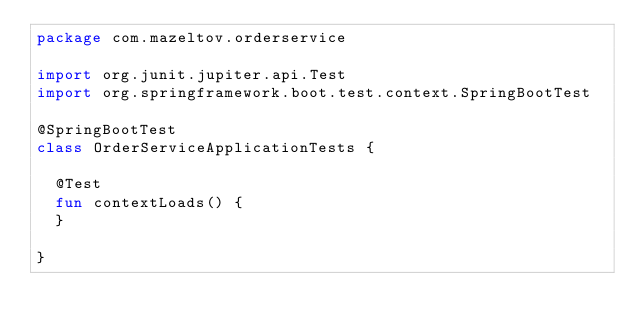Convert code to text. <code><loc_0><loc_0><loc_500><loc_500><_Kotlin_>package com.mazeltov.orderservice

import org.junit.jupiter.api.Test
import org.springframework.boot.test.context.SpringBootTest

@SpringBootTest
class OrderServiceApplicationTests {

	@Test
	fun contextLoads() {
	}

}
</code> 